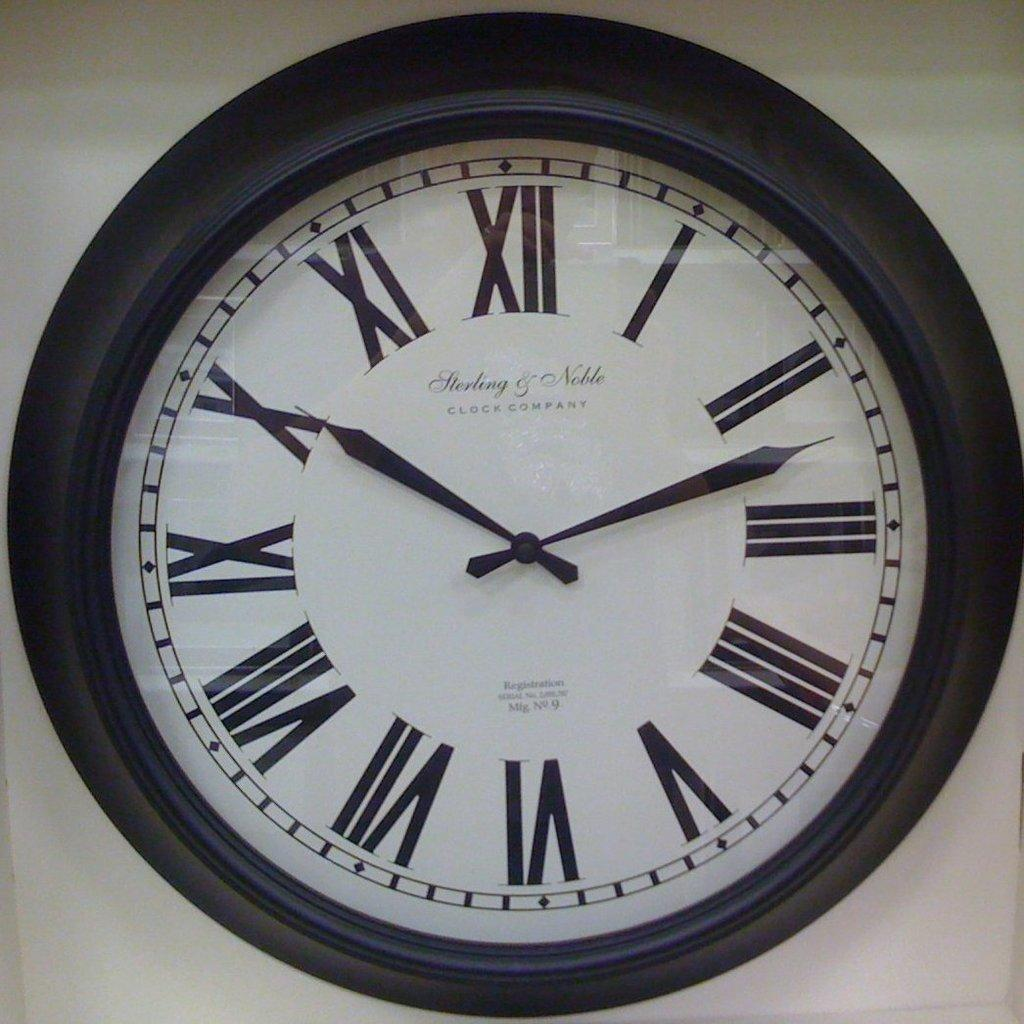Provide a one-sentence caption for the provided image. A black framed clock with roman numerals for numbers. 